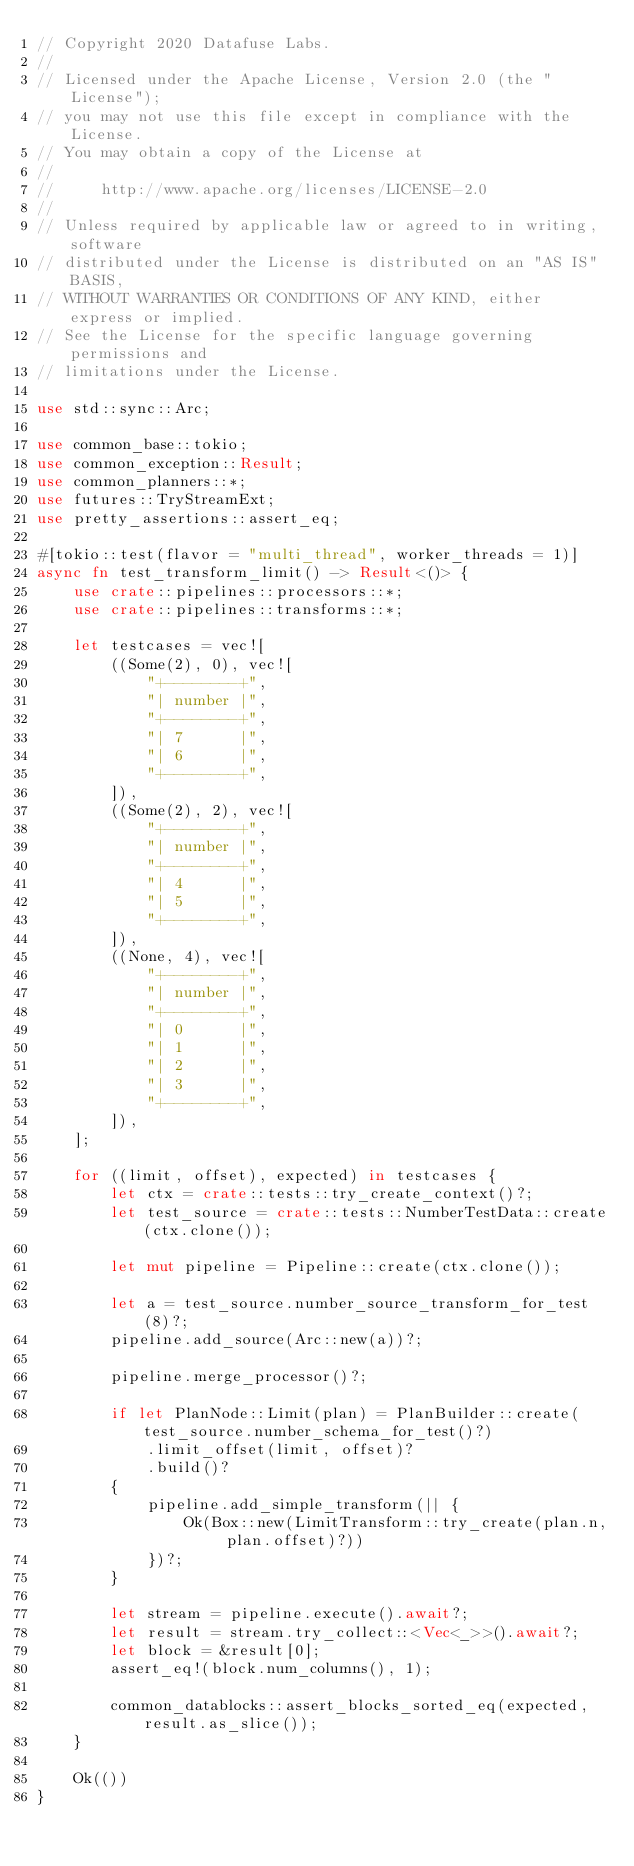<code> <loc_0><loc_0><loc_500><loc_500><_Rust_>// Copyright 2020 Datafuse Labs.
//
// Licensed under the Apache License, Version 2.0 (the "License");
// you may not use this file except in compliance with the License.
// You may obtain a copy of the License at
//
//     http://www.apache.org/licenses/LICENSE-2.0
//
// Unless required by applicable law or agreed to in writing, software
// distributed under the License is distributed on an "AS IS" BASIS,
// WITHOUT WARRANTIES OR CONDITIONS OF ANY KIND, either express or implied.
// See the License for the specific language governing permissions and
// limitations under the License.

use std::sync::Arc;

use common_base::tokio;
use common_exception::Result;
use common_planners::*;
use futures::TryStreamExt;
use pretty_assertions::assert_eq;

#[tokio::test(flavor = "multi_thread", worker_threads = 1)]
async fn test_transform_limit() -> Result<()> {
    use crate::pipelines::processors::*;
    use crate::pipelines::transforms::*;

    let testcases = vec![
        ((Some(2), 0), vec![
            "+--------+",
            "| number |",
            "+--------+",
            "| 7      |",
            "| 6      |",
            "+--------+",
        ]),
        ((Some(2), 2), vec![
            "+--------+",
            "| number |",
            "+--------+",
            "| 4      |",
            "| 5      |",
            "+--------+",
        ]),
        ((None, 4), vec![
            "+--------+",
            "| number |",
            "+--------+",
            "| 0      |",
            "| 1      |",
            "| 2      |",
            "| 3      |",
            "+--------+",
        ]),
    ];

    for ((limit, offset), expected) in testcases {
        let ctx = crate::tests::try_create_context()?;
        let test_source = crate::tests::NumberTestData::create(ctx.clone());

        let mut pipeline = Pipeline::create(ctx.clone());

        let a = test_source.number_source_transform_for_test(8)?;
        pipeline.add_source(Arc::new(a))?;

        pipeline.merge_processor()?;

        if let PlanNode::Limit(plan) = PlanBuilder::create(test_source.number_schema_for_test()?)
            .limit_offset(limit, offset)?
            .build()?
        {
            pipeline.add_simple_transform(|| {
                Ok(Box::new(LimitTransform::try_create(plan.n, plan.offset)?))
            })?;
        }

        let stream = pipeline.execute().await?;
        let result = stream.try_collect::<Vec<_>>().await?;
        let block = &result[0];
        assert_eq!(block.num_columns(), 1);

        common_datablocks::assert_blocks_sorted_eq(expected, result.as_slice());
    }

    Ok(())
}
</code> 